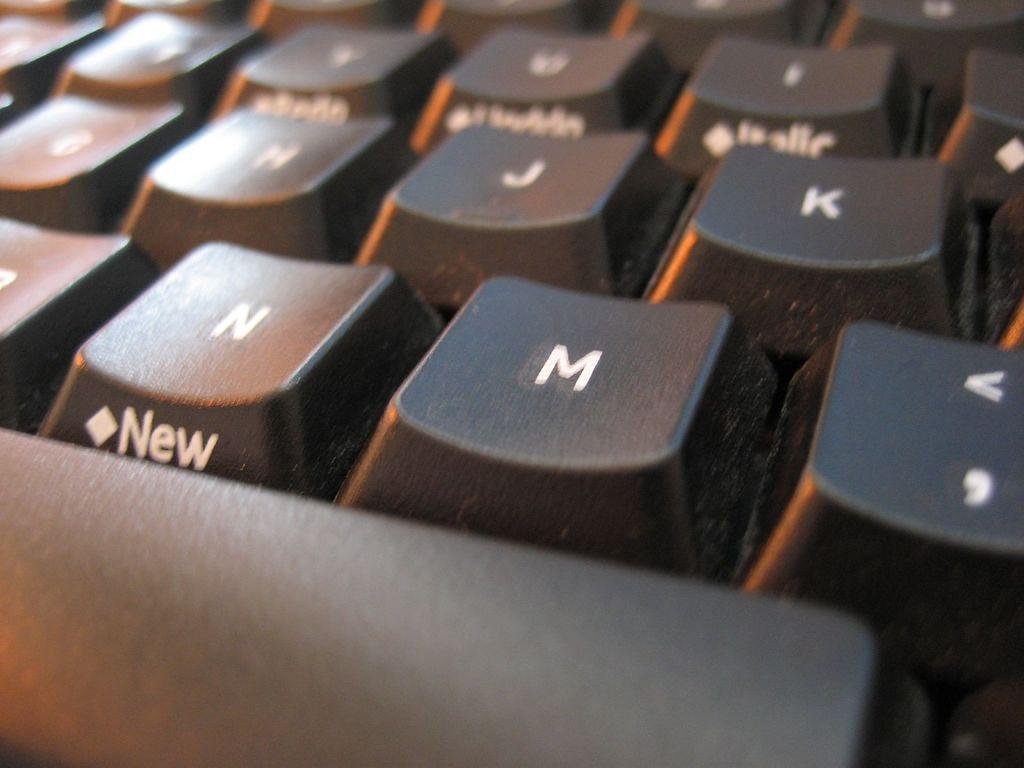<image>
Give a short and clear explanation of the subsequent image. Some keys on a keyboard the closest being the spacebar and then the N & M keys. 